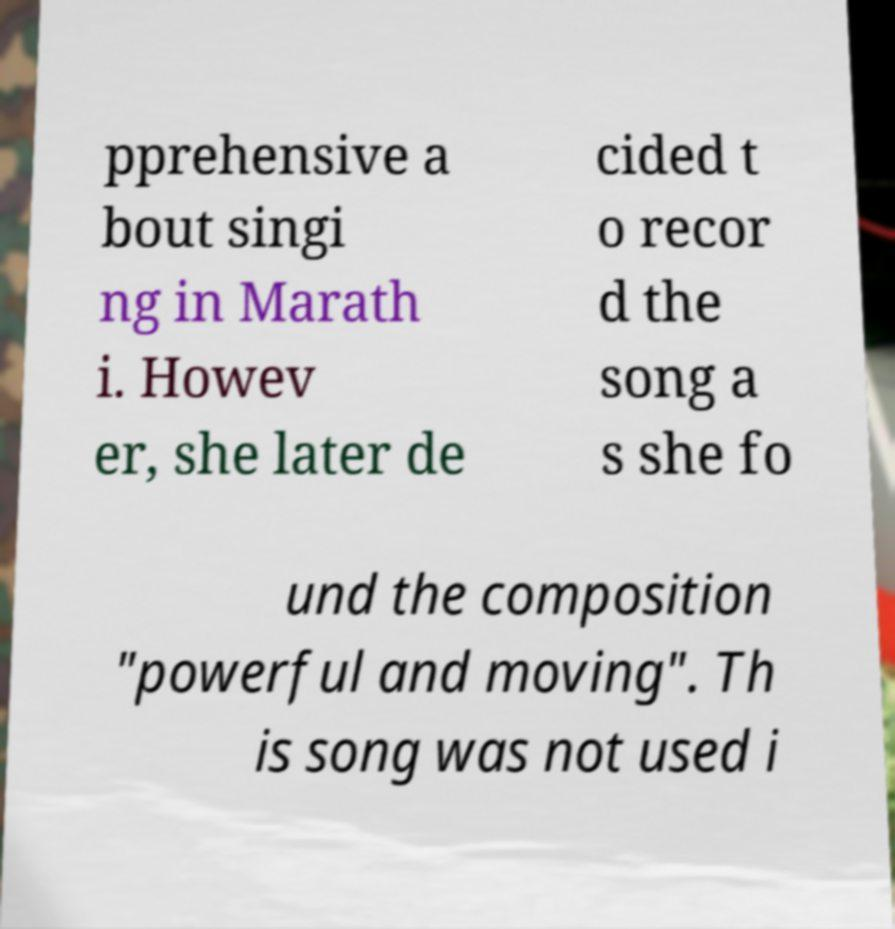Could you extract and type out the text from this image? pprehensive a bout singi ng in Marath i. Howev er, she later de cided t o recor d the song a s she fo und the composition "powerful and moving". Th is song was not used i 